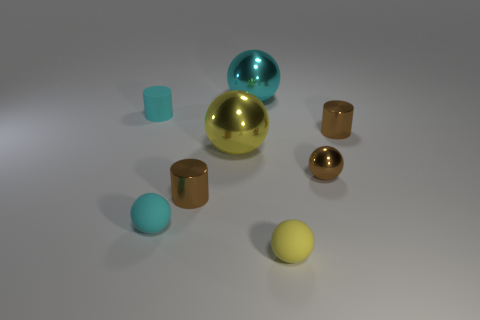Subtract all brown balls. How many balls are left? 4 Subtract all purple spheres. Subtract all cyan blocks. How many spheres are left? 5 Add 1 small yellow metal blocks. How many objects exist? 9 Subtract all cylinders. How many objects are left? 5 Add 7 small cyan rubber objects. How many small cyan rubber objects are left? 9 Add 8 yellow things. How many yellow things exist? 10 Subtract 0 brown blocks. How many objects are left? 8 Subtract all big green matte cylinders. Subtract all large cyan balls. How many objects are left? 7 